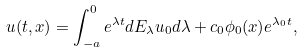<formula> <loc_0><loc_0><loc_500><loc_500>u ( t , x ) = \int _ { - a } ^ { 0 } e ^ { \lambda t } d E _ { \lambda } u _ { 0 } d \lambda + c _ { 0 } \phi _ { 0 } ( x ) e ^ { \lambda _ { 0 } t } ,</formula> 